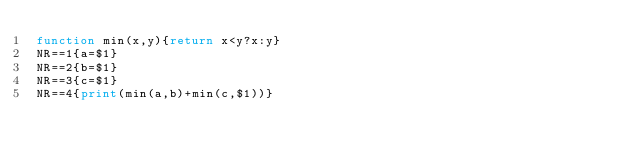Convert code to text. <code><loc_0><loc_0><loc_500><loc_500><_Awk_>function min(x,y){return x<y?x:y}
NR==1{a=$1}
NR==2{b=$1}
NR==3{c=$1}
NR==4{print(min(a,b)+min(c,$1))}
</code> 